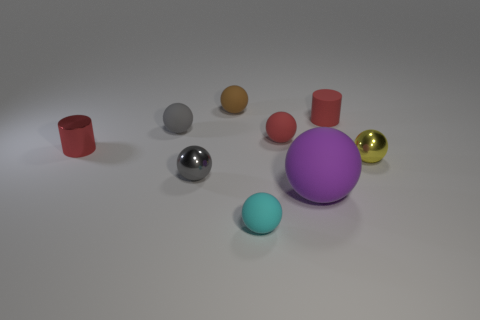Subtract all red cylinders. How many were subtracted if there are1red cylinders left? 1 Subtract 1 balls. How many balls are left? 6 Subtract all red balls. How many balls are left? 6 Subtract all purple spheres. How many spheres are left? 6 Subtract all purple balls. Subtract all green blocks. How many balls are left? 6 Add 1 gray balls. How many objects exist? 10 Subtract all cylinders. How many objects are left? 7 Add 1 shiny cylinders. How many shiny cylinders are left? 2 Add 3 brown rubber things. How many brown rubber things exist? 4 Subtract 0 red blocks. How many objects are left? 9 